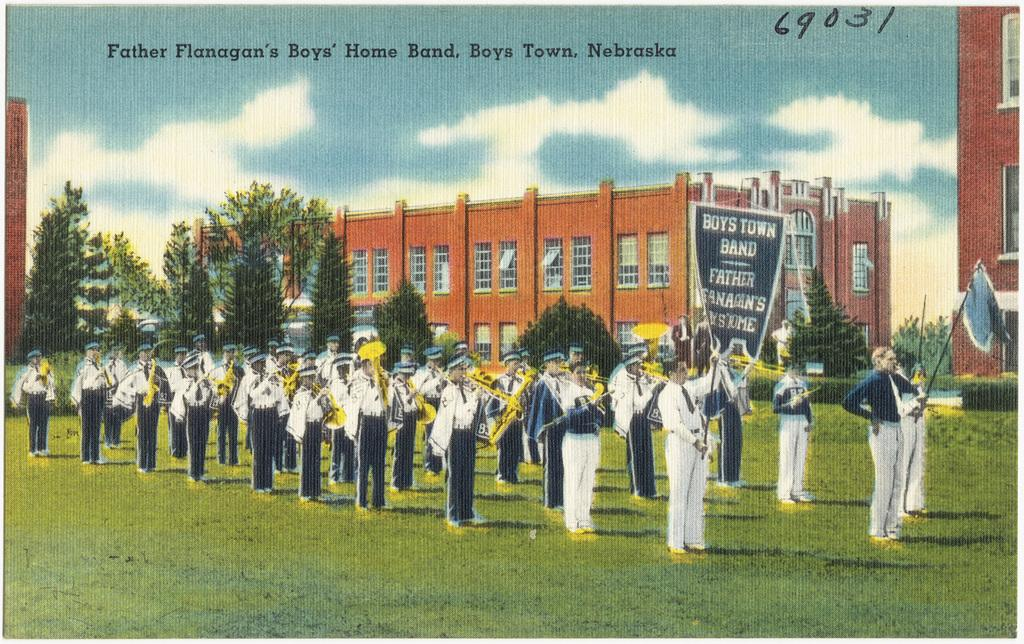Provide a one-sentence caption for the provided image. A group of band members march outside for Boys Town Band. 